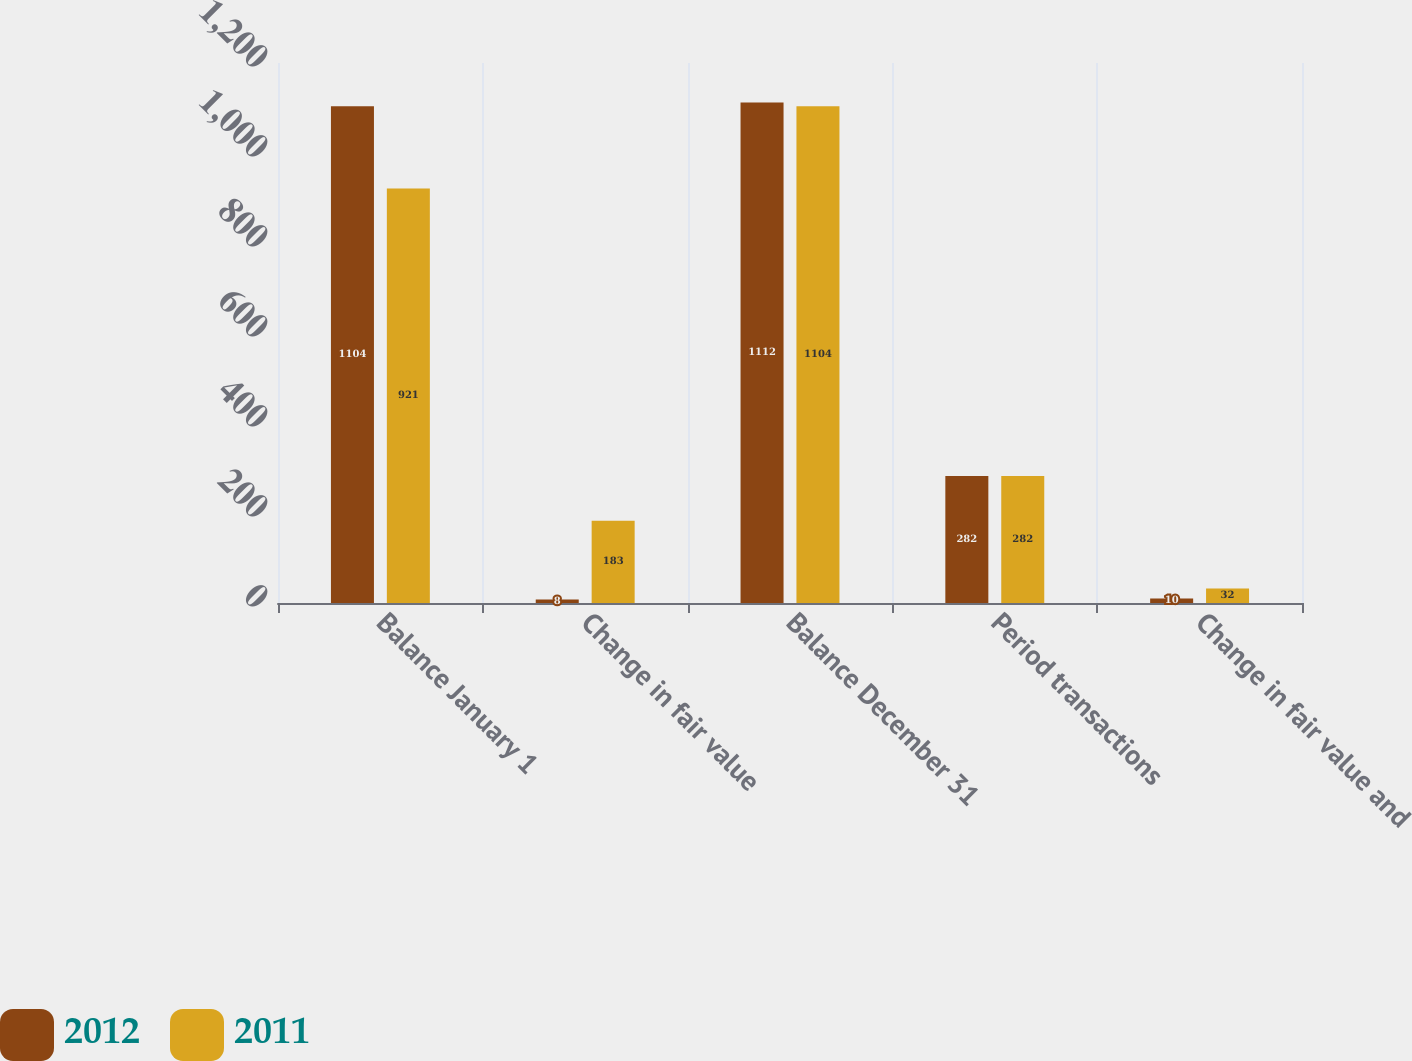Convert chart to OTSL. <chart><loc_0><loc_0><loc_500><loc_500><stacked_bar_chart><ecel><fcel>Balance January 1<fcel>Change in fair value<fcel>Balance December 31<fcel>Period transactions<fcel>Change in fair value and<nl><fcel>2012<fcel>1104<fcel>8<fcel>1112<fcel>282<fcel>10<nl><fcel>2011<fcel>921<fcel>183<fcel>1104<fcel>282<fcel>32<nl></chart> 